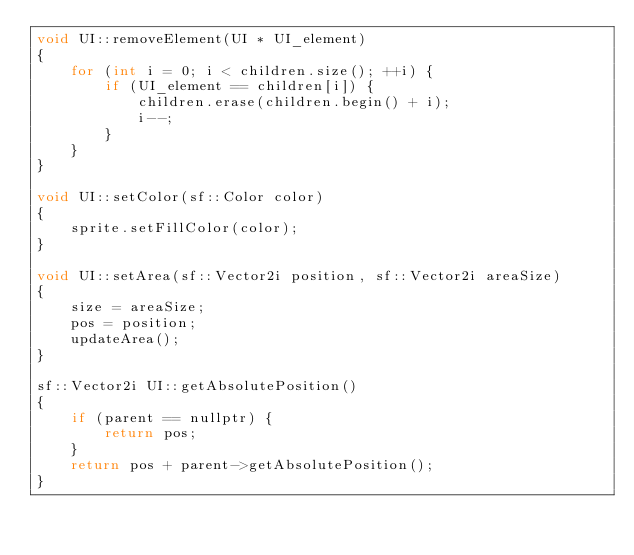<code> <loc_0><loc_0><loc_500><loc_500><_C++_>void UI::removeElement(UI * UI_element)
{
	for (int i = 0; i < children.size(); ++i) {
		if (UI_element == children[i]) {
			children.erase(children.begin() + i);
			i--;
		}
	}
}

void UI::setColor(sf::Color color)
{
	sprite.setFillColor(color);
}

void UI::setArea(sf::Vector2i position, sf::Vector2i areaSize)
{
	size = areaSize;
	pos = position;
	updateArea();
}

sf::Vector2i UI::getAbsolutePosition()
{
	if (parent == nullptr) {
		return pos;
	}
	return pos + parent->getAbsolutePosition();
}


</code> 